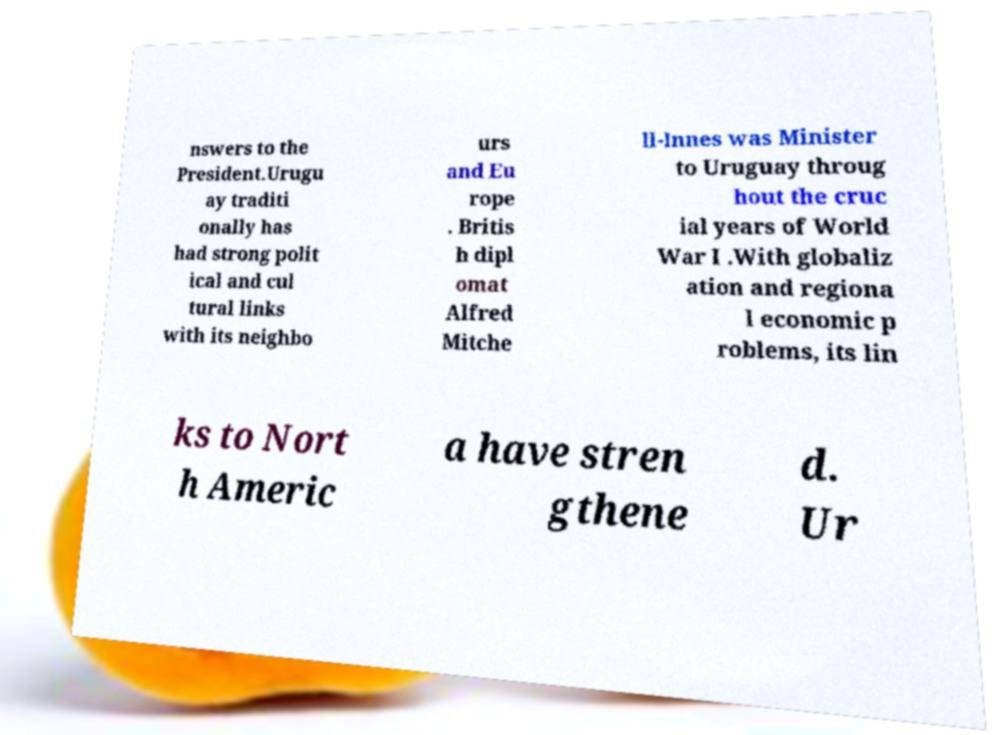What messages or text are displayed in this image? I need them in a readable, typed format. nswers to the President.Urugu ay traditi onally has had strong polit ical and cul tural links with its neighbo urs and Eu rope . Britis h dipl omat Alfred Mitche ll-Innes was Minister to Uruguay throug hout the cruc ial years of World War I .With globaliz ation and regiona l economic p roblems, its lin ks to Nort h Americ a have stren gthene d. Ur 